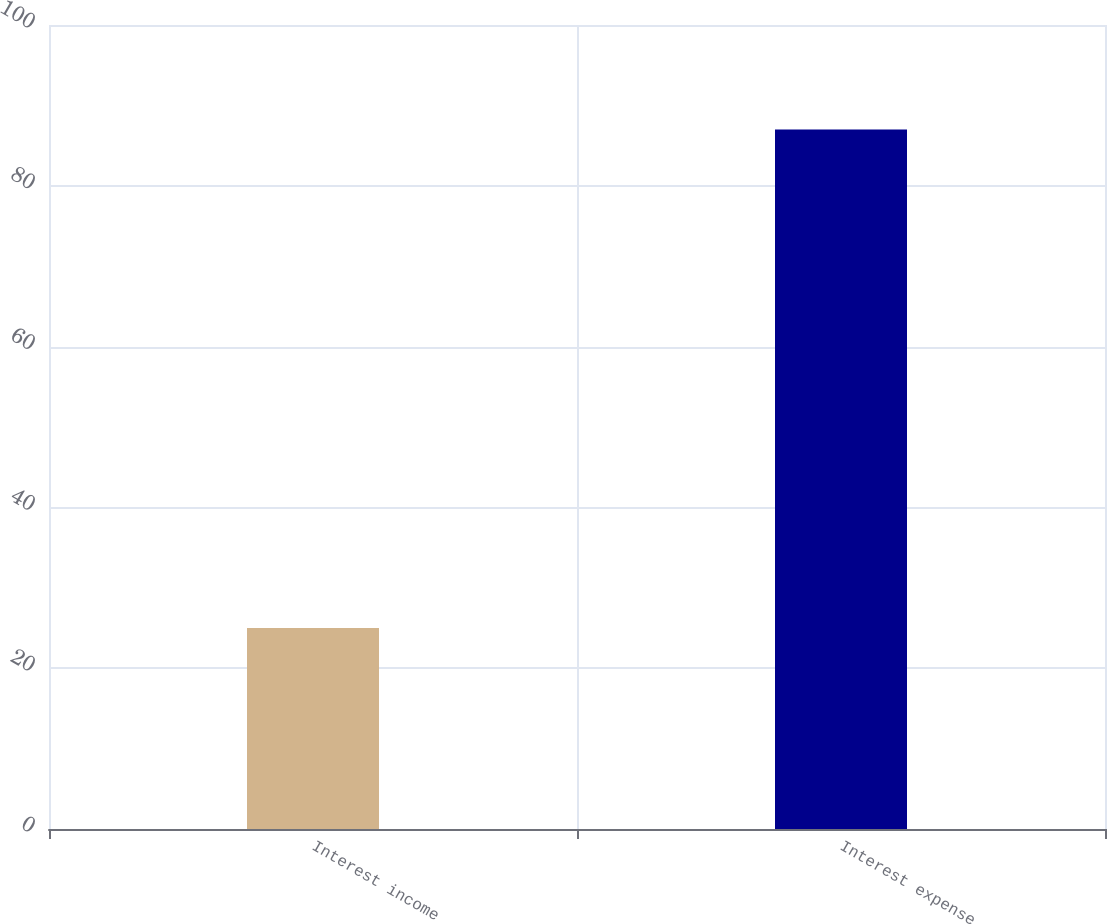<chart> <loc_0><loc_0><loc_500><loc_500><bar_chart><fcel>Interest income<fcel>Interest expense<nl><fcel>25<fcel>87<nl></chart> 